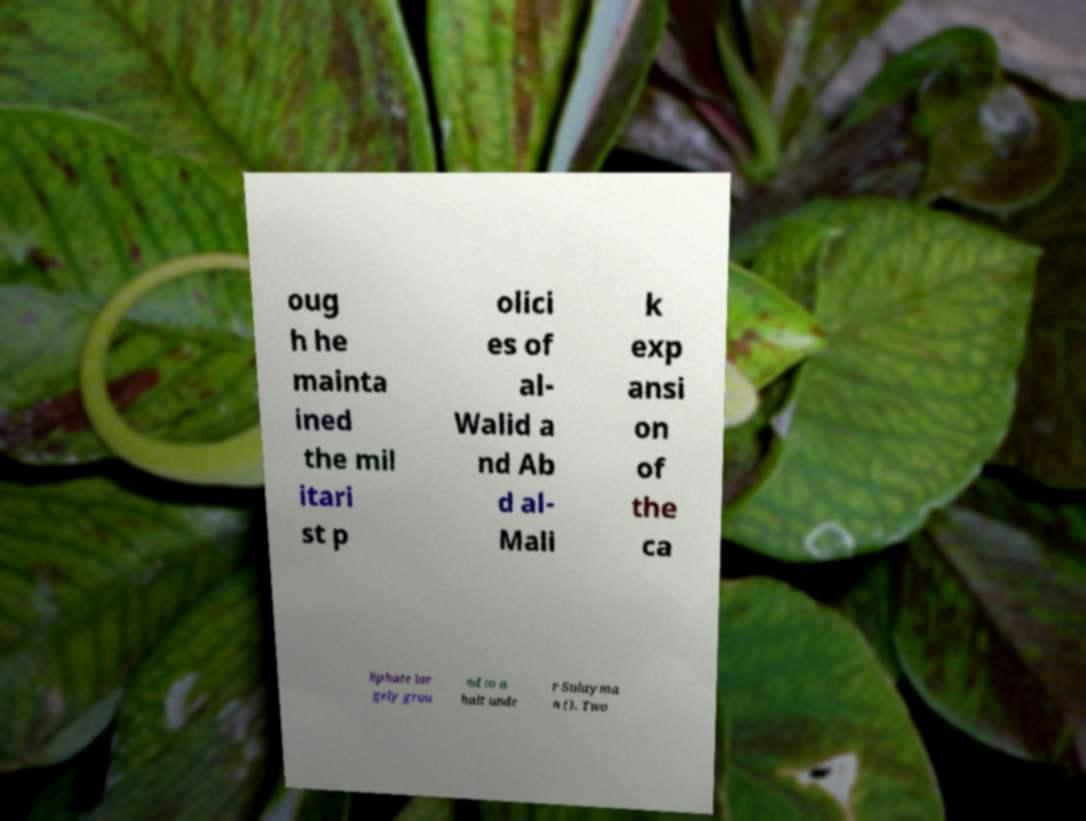There's text embedded in this image that I need extracted. Can you transcribe it verbatim? oug h he mainta ined the mil itari st p olici es of al- Walid a nd Ab d al- Mali k exp ansi on of the ca liphate lar gely grou nd to a halt unde r Sulayma n (). Two 